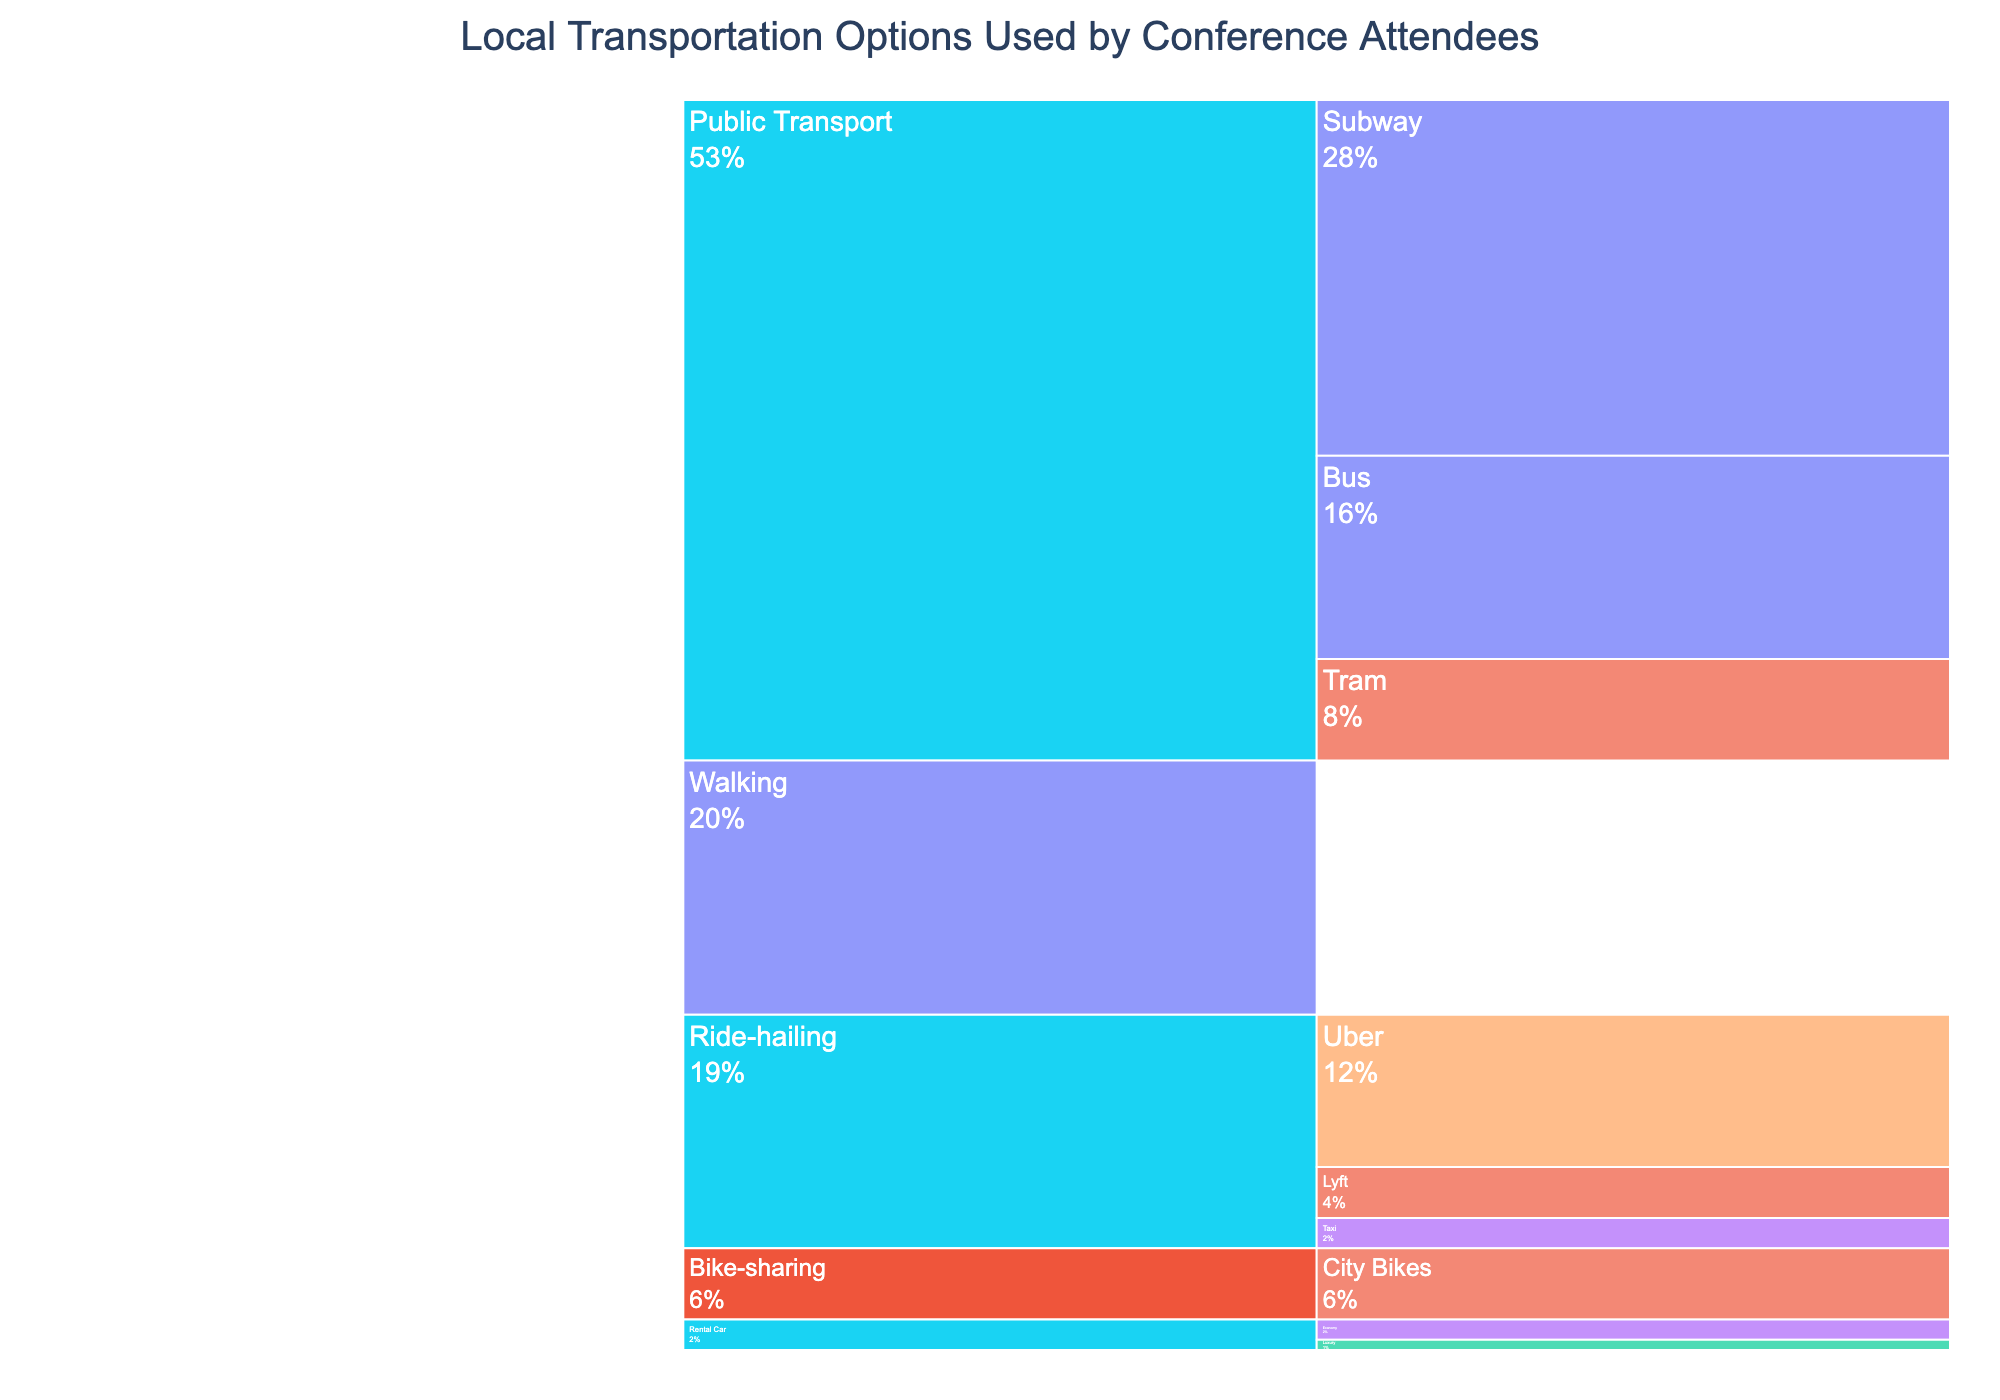What is the most frequently used mode of daily transportation? From the Icicle Chart, find the mode with the highest frequency segment labeled "Daily". The subway under "Public Transport" has the highest percentage for daily use.
Answer: Public Transport (Subway) Which transportation option is used occasionally more frequently, tram or city bikes? Locate the segments labeled "Tram" and "City Bikes", both under their respective modes. Compare their percentages: Tram (10%) and City Bikes (7%).
Answer: Tram What is the combined percentage of all daily transportation options? Identify all segments labeled "Daily" under different modes: Subway (35%), Bus (20%), and Walking (25%). Sum these percentages: 35% + 20% + 25% = 80%.
Answer: 80% Which mode of transportation has the least frequent "Very Rarely" usage? Find the segment with "Very Rarely" frequency. "Luxury" under "Rental Car" has a "Very Rarely" usage at 1%, which is the only instance in the chart.
Answer: Rental Car (Luxury) How does the percentage of Uber's frequent usage compare to the occasional usage of trams? Identify the percentages for "Uber" (15%) and "Tram" (10%). Compare these two values: 15% is greater than 10%.
Answer: Uber's frequent usage is higher What is the total percentage for ride-hailing options? Sum up the percentages for all "Ride-hailing" types: Uber (15%), Lyft (5%), and Taxi (3%). Total: 15% + 5% + 3% = 23%.
Answer: 23% Is there any mode with a frequency categorized as "N/A"? Check each mode and type for an "N/A" frequency label. "Walking" is labeled as "N/A".
Answer: Yes, Walking Which has more daily usage, buses or walking? Compare the daily usage percentages: Bus (20%) and Walking (25%). Walking’s percentage is higher.
Answer: Walking What percentage of conference attendees use public transport daily? Sum the daily usage percentages for all public transport types: Subway (35%) and Bus (20%). Total: 35% + 20% = 55%.
Answer: 55% By how much does the walking daily usage percentage exceed rental car's rare usage? Compare Walking’s daily usage (25%) with Rental Car's rare usage (Economy, 2%). Difference: 25% - 2% = 23%.
Answer: 23% 